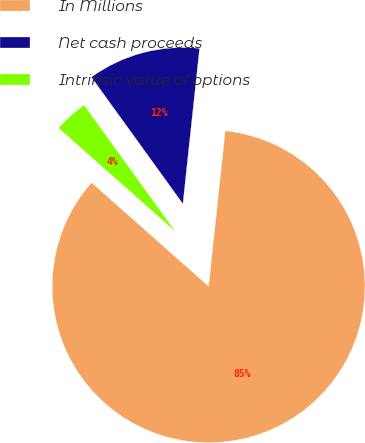Convert chart. <chart><loc_0><loc_0><loc_500><loc_500><pie_chart><fcel>In Millions<fcel>Net cash proceeds<fcel>Intrinsic value of options<nl><fcel>84.84%<fcel>11.65%<fcel>3.51%<nl></chart> 